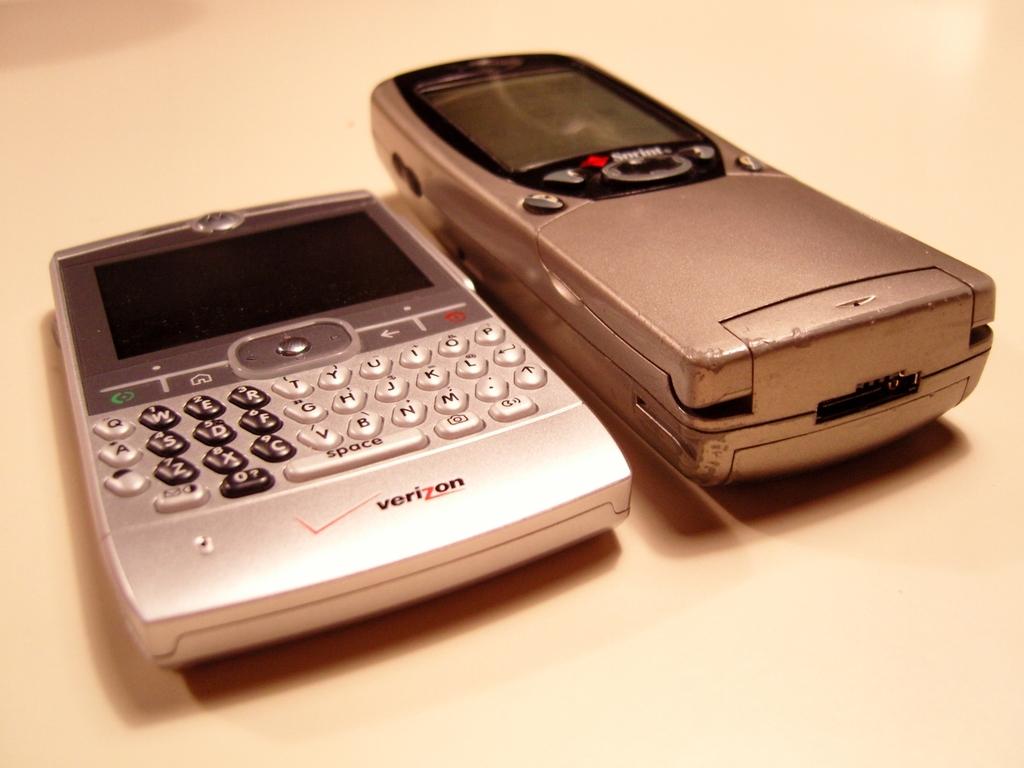What company is on the silver phone?
Ensure brevity in your answer.  Verizon. Is there a "space" key?
Your answer should be very brief. Yes. 